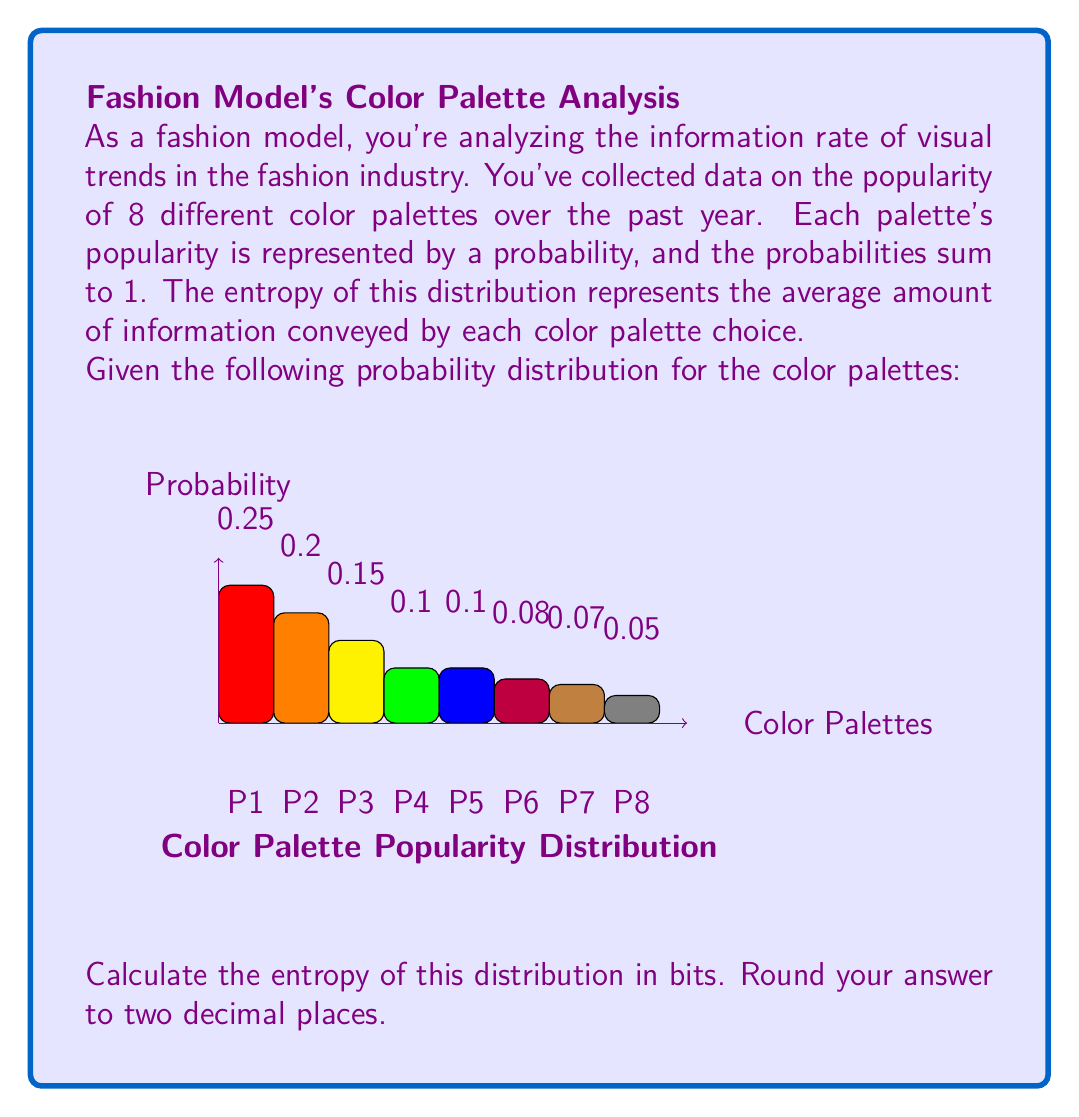Show me your answer to this math problem. To solve this problem, we'll use the entropy formula from information theory:

$$H = -\sum_{i=1}^{n} p_i \log_2(p_i)$$

Where $H$ is the entropy, $p_i$ is the probability of each event, and $n$ is the number of possible events.

Let's calculate each term:

1) $-0.25 \log_2(0.25) = 0.5$
2) $-0.20 \log_2(0.20) = 0.4644$
3) $-0.15 \log_2(0.15) = 0.4019$
4) $-0.10 \log_2(0.10) = 0.3322$ (for both P4 and P5)
5) $-0.08 \log_2(0.08) = 0.2916$
6) $-0.07 \log_2(0.07) = 0.2703$
7) $-0.05 \log_2(0.05) = 0.2161$

Now, we sum all these terms:

$H = 0.5 + 0.4644 + 0.4019 + 0.3322 + 0.3322 + 0.2916 + 0.2703 + 0.2161 = 2.8087$

Rounding to two decimal places, we get 2.81 bits.
Answer: 2.81 bits 